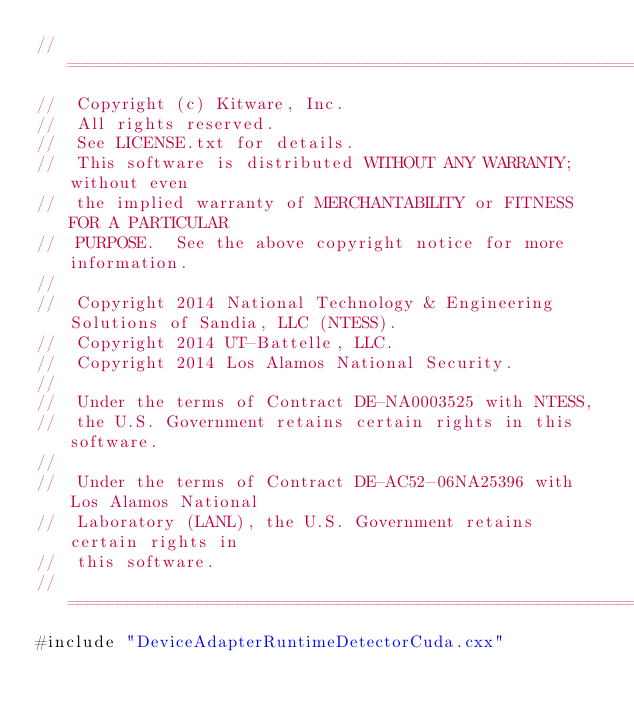<code> <loc_0><loc_0><loc_500><loc_500><_Cuda_>//============================================================================
//  Copyright (c) Kitware, Inc.
//  All rights reserved.
//  See LICENSE.txt for details.
//  This software is distributed WITHOUT ANY WARRANTY; without even
//  the implied warranty of MERCHANTABILITY or FITNESS FOR A PARTICULAR
//  PURPOSE.  See the above copyright notice for more information.
//
//  Copyright 2014 National Technology & Engineering Solutions of Sandia, LLC (NTESS).
//  Copyright 2014 UT-Battelle, LLC.
//  Copyright 2014 Los Alamos National Security.
//
//  Under the terms of Contract DE-NA0003525 with NTESS,
//  the U.S. Government retains certain rights in this software.
//
//  Under the terms of Contract DE-AC52-06NA25396 with Los Alamos National
//  Laboratory (LANL), the U.S. Government retains certain rights in
//  this software.
//============================================================================
#include "DeviceAdapterRuntimeDetectorCuda.cxx"
</code> 